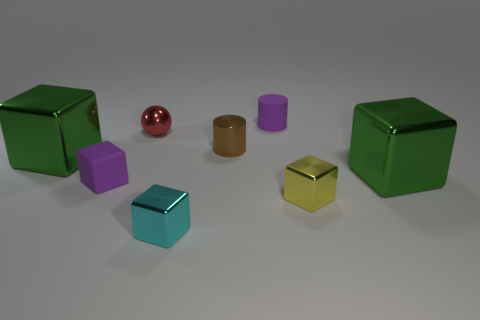What color is the cylinder that is behind the brown metal thing to the left of the tiny yellow metal thing?
Keep it short and to the point. Purple. There is a green block that is left of the green metallic thing to the right of the small block that is on the left side of the small red metallic sphere; what size is it?
Make the answer very short. Large. Is the number of red metallic objects that are in front of the small yellow object less than the number of cyan objects that are to the left of the small shiny ball?
Make the answer very short. No. How many tiny objects are made of the same material as the purple block?
Offer a terse response. 1. There is a large object that is to the right of the cylinder that is behind the red object; is there a tiny metallic object that is in front of it?
Provide a short and direct response. Yes. There is a brown thing that is the same material as the cyan object; what shape is it?
Provide a succinct answer. Cylinder. Are there more small gray shiny cylinders than purple cylinders?
Your answer should be very brief. No. Is the shape of the small cyan thing the same as the large shiny object that is left of the purple cube?
Provide a succinct answer. Yes. What is the material of the small purple block?
Provide a short and direct response. Rubber. What color is the large metallic thing that is left of the purple thing that is in front of the purple matte thing behind the tiny metallic sphere?
Provide a succinct answer. Green. 